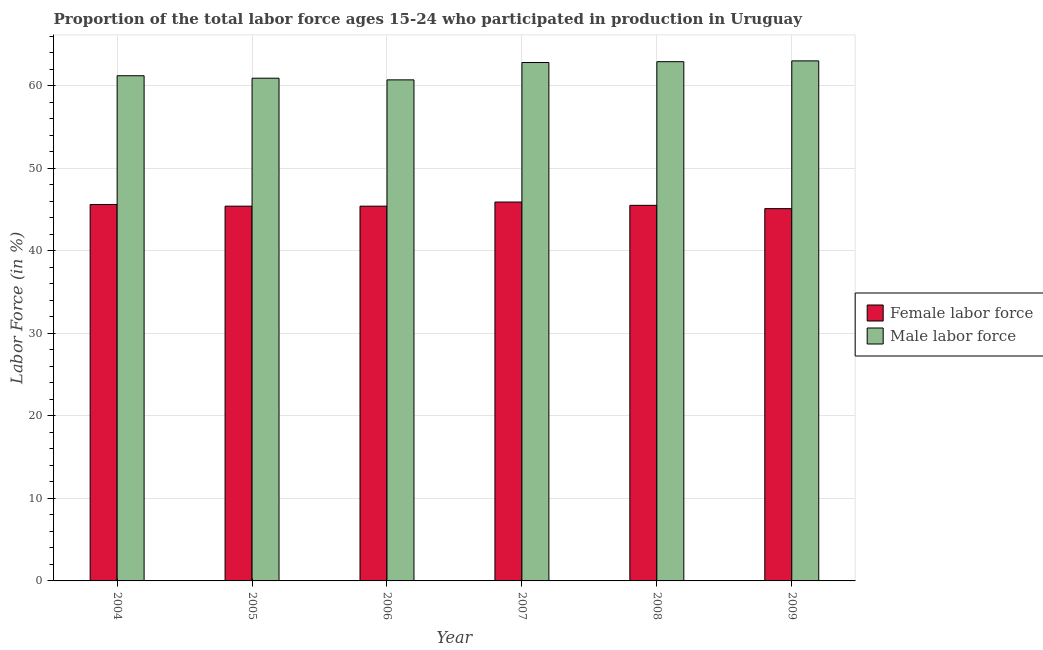How many different coloured bars are there?
Ensure brevity in your answer.  2. Are the number of bars on each tick of the X-axis equal?
Ensure brevity in your answer.  Yes. What is the percentage of male labour force in 2005?
Offer a terse response. 60.9. Across all years, what is the minimum percentage of male labour force?
Offer a very short reply. 60.7. What is the total percentage of female labor force in the graph?
Your answer should be compact. 272.9. What is the difference between the percentage of female labor force in 2008 and that in 2009?
Offer a terse response. 0.4. What is the difference between the percentage of male labour force in 2005 and the percentage of female labor force in 2007?
Provide a succinct answer. -1.9. What is the average percentage of male labour force per year?
Give a very brief answer. 61.92. In the year 2005, what is the difference between the percentage of male labour force and percentage of female labor force?
Your answer should be very brief. 0. In how many years, is the percentage of male labour force greater than 14 %?
Your answer should be compact. 6. What is the ratio of the percentage of male labour force in 2004 to that in 2005?
Provide a succinct answer. 1. Is the percentage of male labour force in 2005 less than that in 2006?
Ensure brevity in your answer.  No. What is the difference between the highest and the second highest percentage of female labor force?
Provide a short and direct response. 0.3. What is the difference between the highest and the lowest percentage of male labour force?
Give a very brief answer. 2.3. In how many years, is the percentage of female labor force greater than the average percentage of female labor force taken over all years?
Your answer should be very brief. 3. What does the 1st bar from the left in 2004 represents?
Give a very brief answer. Female labor force. What does the 1st bar from the right in 2007 represents?
Provide a succinct answer. Male labor force. Are all the bars in the graph horizontal?
Your response must be concise. No. How many years are there in the graph?
Provide a short and direct response. 6. Does the graph contain any zero values?
Provide a short and direct response. No. Where does the legend appear in the graph?
Make the answer very short. Center right. How many legend labels are there?
Provide a succinct answer. 2. How are the legend labels stacked?
Offer a terse response. Vertical. What is the title of the graph?
Offer a very short reply. Proportion of the total labor force ages 15-24 who participated in production in Uruguay. Does "From Government" appear as one of the legend labels in the graph?
Your answer should be very brief. No. What is the label or title of the Y-axis?
Your response must be concise. Labor Force (in %). What is the Labor Force (in %) in Female labor force in 2004?
Keep it short and to the point. 45.6. What is the Labor Force (in %) of Male labor force in 2004?
Keep it short and to the point. 61.2. What is the Labor Force (in %) in Female labor force in 2005?
Provide a succinct answer. 45.4. What is the Labor Force (in %) in Male labor force in 2005?
Provide a short and direct response. 60.9. What is the Labor Force (in %) in Female labor force in 2006?
Your answer should be compact. 45.4. What is the Labor Force (in %) in Male labor force in 2006?
Your answer should be very brief. 60.7. What is the Labor Force (in %) of Female labor force in 2007?
Your answer should be compact. 45.9. What is the Labor Force (in %) in Male labor force in 2007?
Give a very brief answer. 62.8. What is the Labor Force (in %) in Female labor force in 2008?
Give a very brief answer. 45.5. What is the Labor Force (in %) in Male labor force in 2008?
Ensure brevity in your answer.  62.9. What is the Labor Force (in %) of Female labor force in 2009?
Give a very brief answer. 45.1. Across all years, what is the maximum Labor Force (in %) of Female labor force?
Offer a very short reply. 45.9. Across all years, what is the minimum Labor Force (in %) of Female labor force?
Make the answer very short. 45.1. Across all years, what is the minimum Labor Force (in %) in Male labor force?
Your response must be concise. 60.7. What is the total Labor Force (in %) of Female labor force in the graph?
Keep it short and to the point. 272.9. What is the total Labor Force (in %) of Male labor force in the graph?
Your response must be concise. 371.5. What is the difference between the Labor Force (in %) of Male labor force in 2004 and that in 2005?
Keep it short and to the point. 0.3. What is the difference between the Labor Force (in %) of Male labor force in 2004 and that in 2006?
Provide a short and direct response. 0.5. What is the difference between the Labor Force (in %) in Male labor force in 2004 and that in 2007?
Your response must be concise. -1.6. What is the difference between the Labor Force (in %) in Female labor force in 2004 and that in 2009?
Your answer should be very brief. 0.5. What is the difference between the Labor Force (in %) in Female labor force in 2005 and that in 2006?
Your answer should be compact. 0. What is the difference between the Labor Force (in %) of Female labor force in 2005 and that in 2007?
Offer a very short reply. -0.5. What is the difference between the Labor Force (in %) in Female labor force in 2005 and that in 2008?
Offer a terse response. -0.1. What is the difference between the Labor Force (in %) of Female labor force in 2005 and that in 2009?
Your answer should be very brief. 0.3. What is the difference between the Labor Force (in %) in Male labor force in 2006 and that in 2007?
Make the answer very short. -2.1. What is the difference between the Labor Force (in %) of Male labor force in 2007 and that in 2008?
Keep it short and to the point. -0.1. What is the difference between the Labor Force (in %) in Female labor force in 2007 and that in 2009?
Give a very brief answer. 0.8. What is the difference between the Labor Force (in %) in Female labor force in 2008 and that in 2009?
Provide a succinct answer. 0.4. What is the difference between the Labor Force (in %) in Male labor force in 2008 and that in 2009?
Your response must be concise. -0.1. What is the difference between the Labor Force (in %) of Female labor force in 2004 and the Labor Force (in %) of Male labor force in 2005?
Keep it short and to the point. -15.3. What is the difference between the Labor Force (in %) of Female labor force in 2004 and the Labor Force (in %) of Male labor force in 2006?
Your answer should be compact. -15.1. What is the difference between the Labor Force (in %) in Female labor force in 2004 and the Labor Force (in %) in Male labor force in 2007?
Ensure brevity in your answer.  -17.2. What is the difference between the Labor Force (in %) of Female labor force in 2004 and the Labor Force (in %) of Male labor force in 2008?
Your answer should be compact. -17.3. What is the difference between the Labor Force (in %) in Female labor force in 2004 and the Labor Force (in %) in Male labor force in 2009?
Give a very brief answer. -17.4. What is the difference between the Labor Force (in %) in Female labor force in 2005 and the Labor Force (in %) in Male labor force in 2006?
Ensure brevity in your answer.  -15.3. What is the difference between the Labor Force (in %) in Female labor force in 2005 and the Labor Force (in %) in Male labor force in 2007?
Provide a succinct answer. -17.4. What is the difference between the Labor Force (in %) in Female labor force in 2005 and the Labor Force (in %) in Male labor force in 2008?
Ensure brevity in your answer.  -17.5. What is the difference between the Labor Force (in %) in Female labor force in 2005 and the Labor Force (in %) in Male labor force in 2009?
Your answer should be very brief. -17.6. What is the difference between the Labor Force (in %) of Female labor force in 2006 and the Labor Force (in %) of Male labor force in 2007?
Offer a terse response. -17.4. What is the difference between the Labor Force (in %) of Female labor force in 2006 and the Labor Force (in %) of Male labor force in 2008?
Offer a very short reply. -17.5. What is the difference between the Labor Force (in %) in Female labor force in 2006 and the Labor Force (in %) in Male labor force in 2009?
Give a very brief answer. -17.6. What is the difference between the Labor Force (in %) in Female labor force in 2007 and the Labor Force (in %) in Male labor force in 2008?
Your answer should be compact. -17. What is the difference between the Labor Force (in %) of Female labor force in 2007 and the Labor Force (in %) of Male labor force in 2009?
Keep it short and to the point. -17.1. What is the difference between the Labor Force (in %) of Female labor force in 2008 and the Labor Force (in %) of Male labor force in 2009?
Keep it short and to the point. -17.5. What is the average Labor Force (in %) of Female labor force per year?
Your answer should be very brief. 45.48. What is the average Labor Force (in %) of Male labor force per year?
Provide a succinct answer. 61.92. In the year 2004, what is the difference between the Labor Force (in %) in Female labor force and Labor Force (in %) in Male labor force?
Give a very brief answer. -15.6. In the year 2005, what is the difference between the Labor Force (in %) of Female labor force and Labor Force (in %) of Male labor force?
Ensure brevity in your answer.  -15.5. In the year 2006, what is the difference between the Labor Force (in %) of Female labor force and Labor Force (in %) of Male labor force?
Offer a terse response. -15.3. In the year 2007, what is the difference between the Labor Force (in %) of Female labor force and Labor Force (in %) of Male labor force?
Provide a succinct answer. -16.9. In the year 2008, what is the difference between the Labor Force (in %) in Female labor force and Labor Force (in %) in Male labor force?
Provide a short and direct response. -17.4. In the year 2009, what is the difference between the Labor Force (in %) of Female labor force and Labor Force (in %) of Male labor force?
Provide a succinct answer. -17.9. What is the ratio of the Labor Force (in %) of Female labor force in 2004 to that in 2005?
Ensure brevity in your answer.  1. What is the ratio of the Labor Force (in %) in Male labor force in 2004 to that in 2005?
Ensure brevity in your answer.  1. What is the ratio of the Labor Force (in %) in Female labor force in 2004 to that in 2006?
Ensure brevity in your answer.  1. What is the ratio of the Labor Force (in %) in Male labor force in 2004 to that in 2006?
Offer a terse response. 1.01. What is the ratio of the Labor Force (in %) of Male labor force in 2004 to that in 2007?
Make the answer very short. 0.97. What is the ratio of the Labor Force (in %) in Female labor force in 2004 to that in 2008?
Your answer should be very brief. 1. What is the ratio of the Labor Force (in %) in Male labor force in 2004 to that in 2008?
Provide a short and direct response. 0.97. What is the ratio of the Labor Force (in %) of Female labor force in 2004 to that in 2009?
Provide a short and direct response. 1.01. What is the ratio of the Labor Force (in %) in Male labor force in 2004 to that in 2009?
Your answer should be very brief. 0.97. What is the ratio of the Labor Force (in %) of Female labor force in 2005 to that in 2006?
Make the answer very short. 1. What is the ratio of the Labor Force (in %) of Male labor force in 2005 to that in 2007?
Offer a terse response. 0.97. What is the ratio of the Labor Force (in %) in Male labor force in 2005 to that in 2008?
Make the answer very short. 0.97. What is the ratio of the Labor Force (in %) in Female labor force in 2005 to that in 2009?
Your response must be concise. 1.01. What is the ratio of the Labor Force (in %) in Male labor force in 2005 to that in 2009?
Make the answer very short. 0.97. What is the ratio of the Labor Force (in %) in Female labor force in 2006 to that in 2007?
Give a very brief answer. 0.99. What is the ratio of the Labor Force (in %) in Male labor force in 2006 to that in 2007?
Offer a terse response. 0.97. What is the ratio of the Labor Force (in %) in Female labor force in 2006 to that in 2008?
Offer a very short reply. 1. What is the ratio of the Labor Force (in %) of Male labor force in 2006 to that in 2008?
Ensure brevity in your answer.  0.96. What is the ratio of the Labor Force (in %) of Female labor force in 2006 to that in 2009?
Offer a very short reply. 1.01. What is the ratio of the Labor Force (in %) of Male labor force in 2006 to that in 2009?
Keep it short and to the point. 0.96. What is the ratio of the Labor Force (in %) of Female labor force in 2007 to that in 2008?
Provide a short and direct response. 1.01. What is the ratio of the Labor Force (in %) in Female labor force in 2007 to that in 2009?
Keep it short and to the point. 1.02. What is the ratio of the Labor Force (in %) of Female labor force in 2008 to that in 2009?
Your answer should be compact. 1.01. What is the ratio of the Labor Force (in %) of Male labor force in 2008 to that in 2009?
Your answer should be very brief. 1. What is the difference between the highest and the lowest Labor Force (in %) in Female labor force?
Offer a terse response. 0.8. 